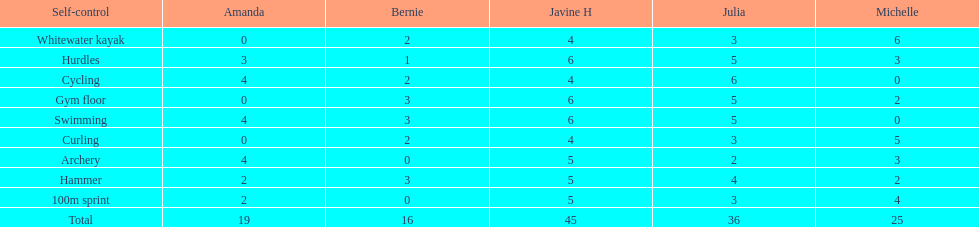What is the last discipline listed on this chart? 100m sprint. 